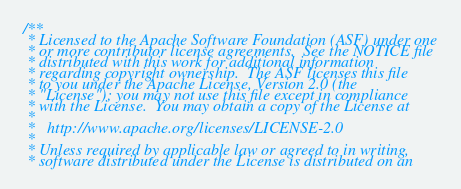Convert code to text. <code><loc_0><loc_0><loc_500><loc_500><_C_>/**
 * Licensed to the Apache Software Foundation (ASF) under one
 * or more contributor license agreements.  See the NOTICE file
 * distributed with this work for additional information
 * regarding copyright ownership.  The ASF licenses this file
 * to you under the Apache License, Version 2.0 (the
 * "License"); you may not use this file except in compliance
 * with the License.  You may obtain a copy of the License at
 *
 *   http://www.apache.org/licenses/LICENSE-2.0
 *
 * Unless required by applicable law or agreed to in writing,
 * software distributed under the License is distributed on an</code> 